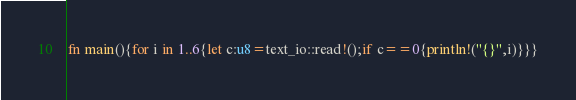<code> <loc_0><loc_0><loc_500><loc_500><_Rust_>fn main(){for i in 1..6{let c:u8=text_io::read!();if c==0{println!("{}",i)}}}</code> 